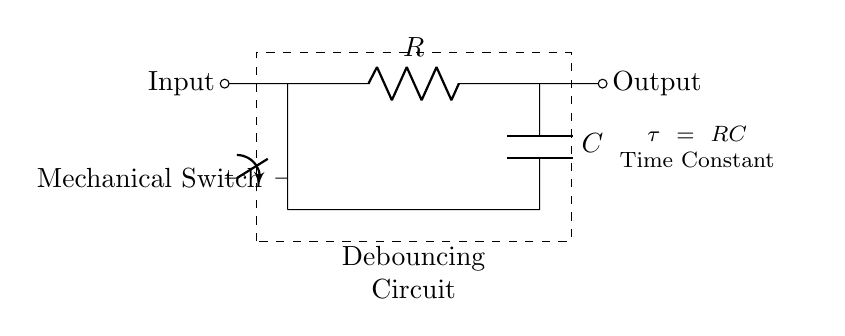What components are in this circuit? The circuit contains a resistor labeled R, a capacitor labeled C, and a mechanical switch. These components are clearly marked on the diagram.
Answer: Resistor, Capacitor, Mechanical Switch What type of circuit is this? The diagram represents a series RC circuit designed specifically for debouncing mechanical switches. This is indicated by the context given in the text "Debouncing Circuit."
Answer: Series RC Circuit What is the time constant of the circuit? The time constant, which is denoted by τ, is calculated using the formula τ = RC. This is annotated in the circuit, indicating the relationship between the resistor and capacitor in determining the time constant.
Answer: RC How does the mechanical switch function in the circuit? The mechanical switch serves as an input to the circuit and is positioned before the resistor. When pressed, it allows the current to flow through the resistor and capacitor, enabling the debouncing effect.
Answer: Input for current control What happens to the output when the switch is pressed? When the switch is pressed, the current flows through the resistor and capacitor, causing the output to stabilize over time as the capacitor charges or discharges. This process reduces the bounce effect of the switch.
Answer: Stabilizes output over time What is the purpose of the capacitor in this circuit? The capacitor's purpose is to smooth out the transitions and prevent false triggering that can occur due to bouncing when the mechanical switch contacts open and close.
Answer: Prevents false triggering 